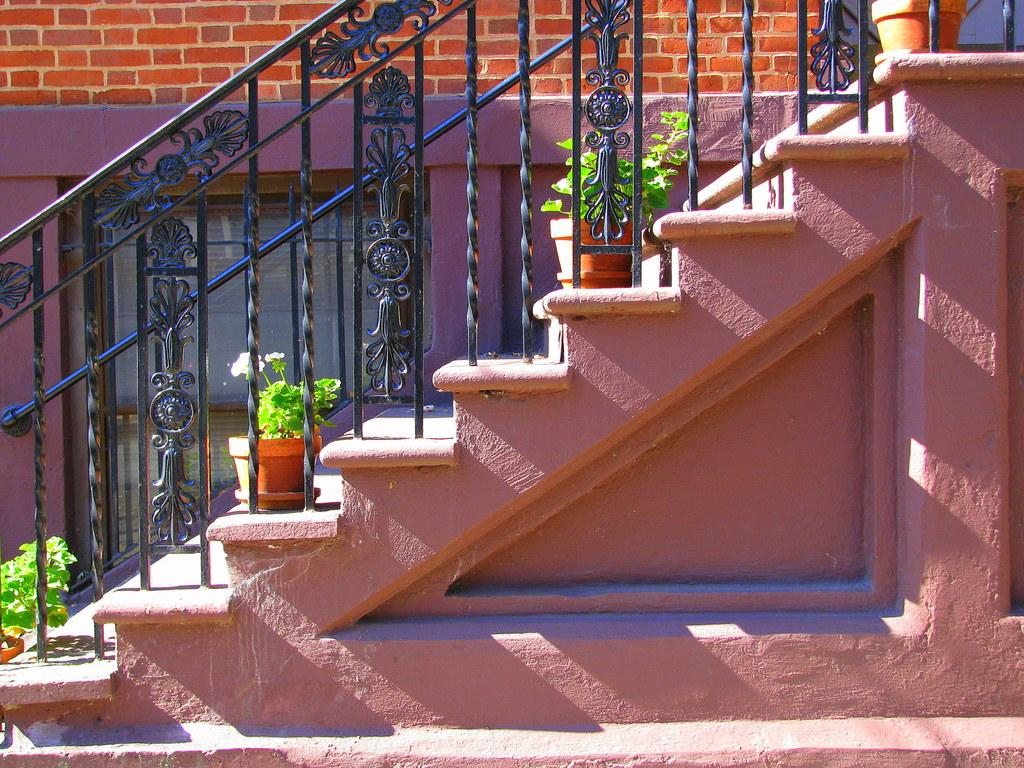What type of structure is present in the image? There is a staircase in the image. What material are the grilles in the image made of? The grilles in the image are made of iron. What type of vegetation can be seen in the image? There are plants in flower pots in the image. What is behind the iron grilles in the image? There is a wall with a window behind the iron grilles in the image. How does the beginner learn the trick of opening the iron grilles in the image? There is no indication in the image that a trick is involved in opening the iron grilles, nor is there any mention of a beginner. 